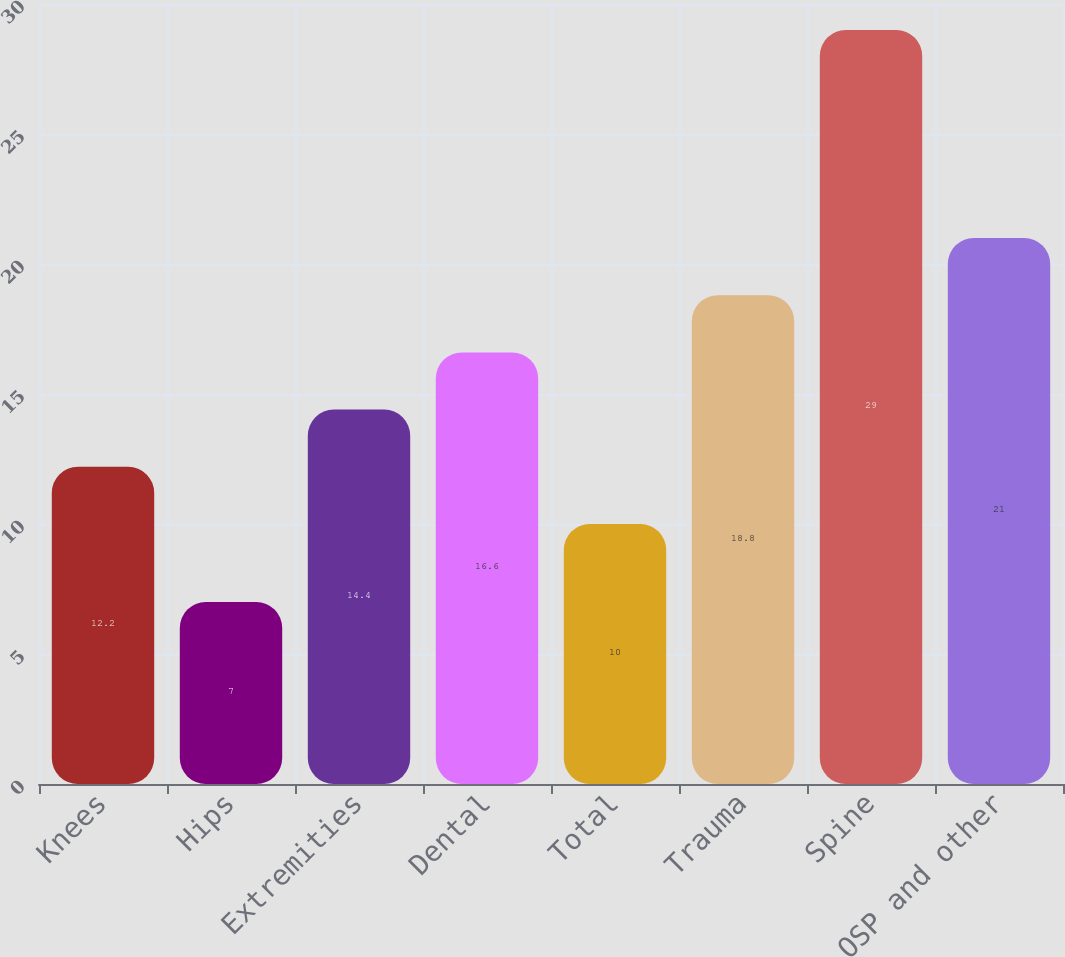Convert chart to OTSL. <chart><loc_0><loc_0><loc_500><loc_500><bar_chart><fcel>Knees<fcel>Hips<fcel>Extremities<fcel>Dental<fcel>Total<fcel>Trauma<fcel>Spine<fcel>OSP and other<nl><fcel>12.2<fcel>7<fcel>14.4<fcel>16.6<fcel>10<fcel>18.8<fcel>29<fcel>21<nl></chart> 